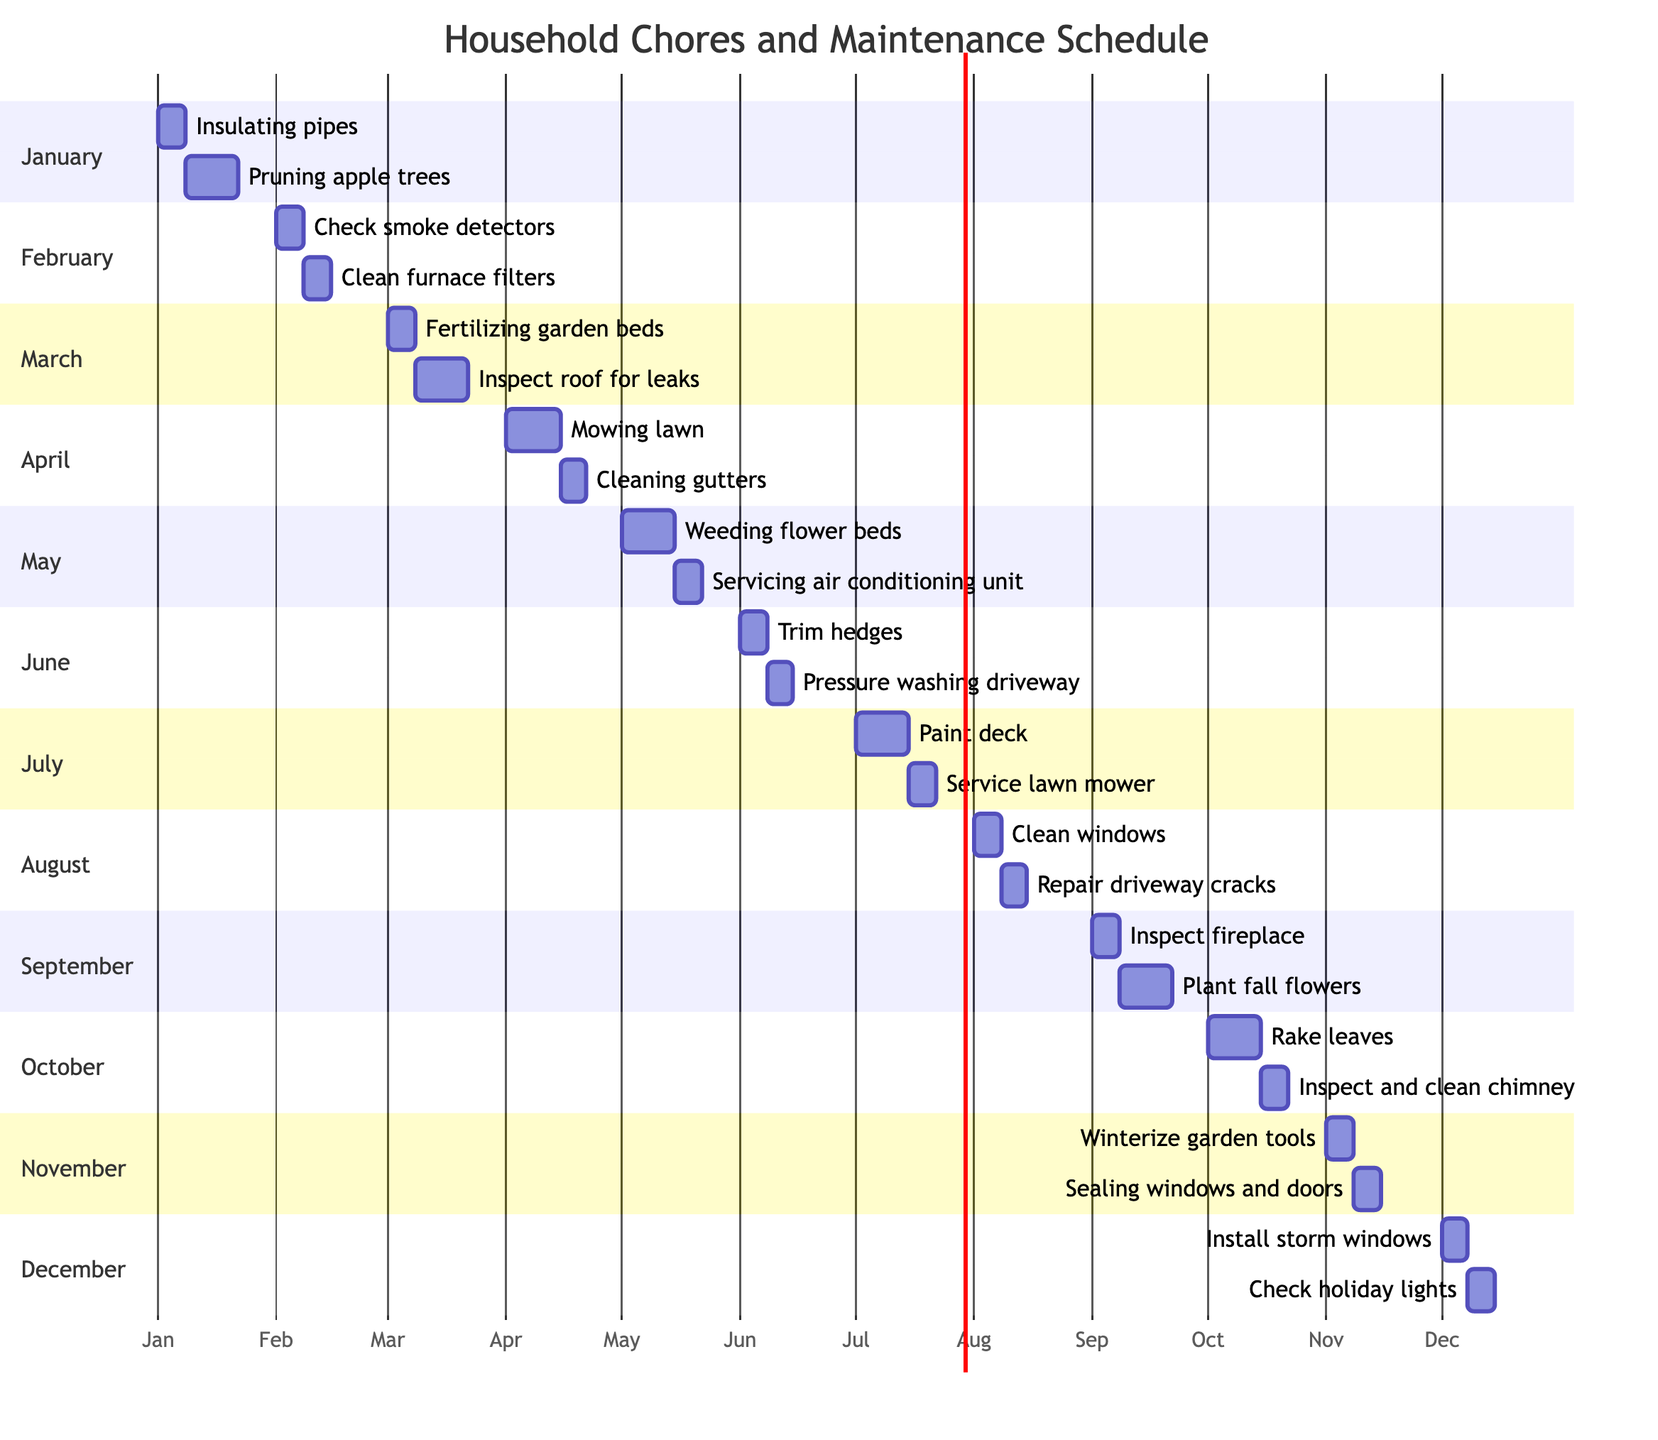What is the duration of the task "Pruning apple trees"? The task "Pruning apple trees" is scheduled to take place in January and has a duration of 2 weeks, as indicated in the task details for that month.
Answer: 2 weeks How many tasks are scheduled for the month of March? In March, there are two tasks listed: "Fertilizing garden beds" and "Inspect roof for leaks." Therefore, the total count of tasks for March is 2.
Answer: 2 Which month has the task "Inspect and clean chimney"? The task "Inspect and clean chimney" is scheduled for October. It is the only task recorded for that point in time within the October section of the diagram.
Answer: October What is the total number of tasks that last for one week? By reviewing the tasks scheduled across all months, the ones that last for one week are: "Check smoke detectors," "Clean furnace filters," "Fertilizing garden beds," "Cleaning gutters," "Servicing air conditioning unit," "Trim hedges," "Pressure washing driveway," "Clean windows," "Repair driveway cracks," "Inspect fireplace," "Inspect and clean chimney," "Winterize garden tools," "Sealing windows and doors," "Install storm windows," and "Check holiday lights." Counting these tasks, the total is 14.
Answer: 14 Which task has the longest duration in the month of July? In July, there are two tasks: "Paint deck" and "Service lawn mower." "Paint deck" has a duration of 2 weeks, which is longer than "Service lawn mower," which lasts for 1 week. Therefore, "Paint deck" is the task with the longest duration that month.
Answer: Paint deck Which month has tasks that include gardening activities? The months of January, March, May, and September include tasks related to gardening. Specifically, January has "Pruning apple trees," March has "Fertilizing garden beds," May has "Weeding flower beds," and September has "Plant fall flowers." Consequently, these months are primarily assigned gardening activities.
Answer: January, March, May, September What are the tasks scheduled for November? November includes two tasks: "Winterize garden tools" and "Sealing windows and doors." Both tasks are clearly defined in the November section and are scheduled for 1 week each.
Answer: Winterize garden tools, Sealing windows and doors Which task starts first in the year of the schedule? The first task in the schedule is "Insulating pipes," which starts on January 1st and has a duration of 1 week. This position makes it the initial task of the year as per the Gantt chart structure.
Answer: Insulating pipes 